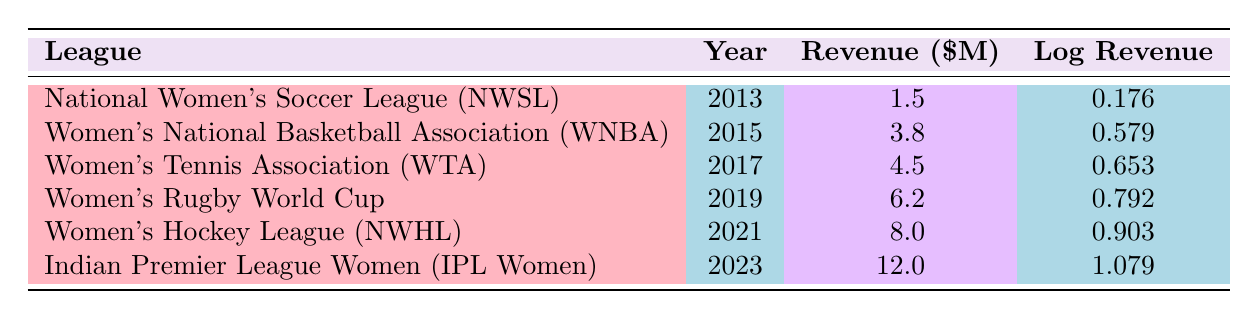What was the revenue of the Women's National Basketball Association in 2015? The table lists the revenue for the Women's National Basketball Association (WNBA) specifically for the year 2015, which is given as 3.8 million dollars.
Answer: 3.8 million dollars Which league saw the highest logarithmic revenue in the year 2023? The table indicates that the Indian Premier League Women (IPL Women) had a logarithmic revenue of 1.079, making it the highest among the leagues listed for the year 2023.
Answer: Indian Premier League Women (IPL Women) What is the total sponsorship revenue from 2013 to 2023 for the leagues represented in the table? The revenue values can be summed: 1.5 + 3.8 + 4.5 + 6.2 + 8.0 + 12.0 = 36.0 million dollars for the period 2013 to 2023.
Answer: 36.0 million dollars Did the Women's Hockey League have a lower revenue than the Women’s Rugby World Cup in 2019? The Women's Hockey League (NWHL) had a revenue of 8.0 million dollars in 2021, while the Women’s Rugby World Cup had a revenue of 6.2 million dollars in 2019. Therefore, the statement is true, as the revenue from WNHL is higher than WRWC's.
Answer: No What is the difference in log revenue between the National Women's Soccer League in 2013 and the Women's Rugby World Cup in 2019? The log revenue for the National Women's Soccer League (NWSL) in 2013 is 0.176, and for the Women’s Rugby World Cup in 2019 it is 0.792. The difference is calculated as 0.792 - 0.176 = 0.616.
Answer: 0.616 How many leagues had revenues surpassing 6 million dollars by 2021? The leagues with revenues surpassing 6 million dollars by 2021 are Women's Rugby World Cup (2019), Women's Hockey League (NWHL) (2021), and Indian Premier League Women (IPL Women) (2023). Three leagues exceed this threshold.
Answer: Three leagues What was the growth trend in sponsorship revenue from 2013 to 2023? Analyzing the revenue from the National Women's Soccer League in 2013 with 1.5 million dollars, increasing to 12.0 million dollars for Indian Premier League Women in 2023 indicates a consistent upward trend in sponsorship revenue over this decade.
Answer: Consistent upward trend Is it true that the Women's Tennis Association had a log revenue less than 0.7? The log revenue for the Women's Tennis Association (WTA) in 2017 is given as 0.653, which is indeed less than 0.7. Therefore, the statement is true.
Answer: Yes 